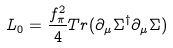Convert formula to latex. <formula><loc_0><loc_0><loc_500><loc_500>L _ { 0 } = \frac { f _ { \pi } ^ { 2 } } { 4 } T r ( \partial _ { \mu } \Sigma ^ { \dagger } \partial _ { \mu } \Sigma )</formula> 